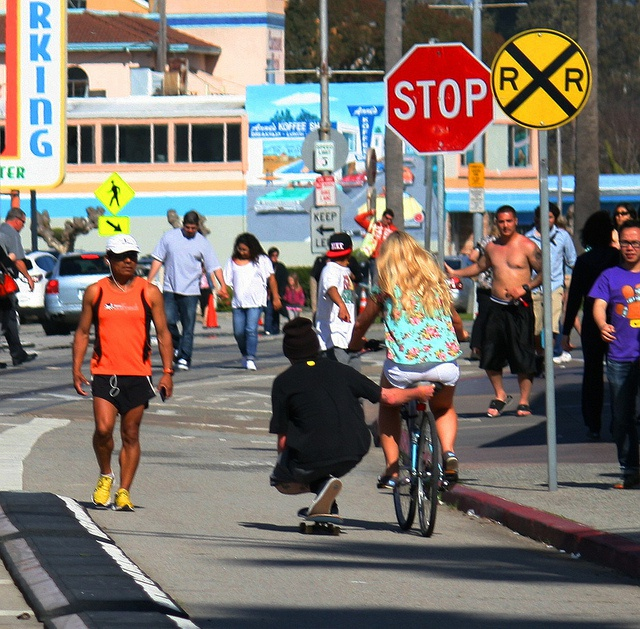Describe the objects in this image and their specific colors. I can see people in beige, red, black, maroon, and brown tones, people in beige, black, maroon, gray, and salmon tones, people in beige, tan, cyan, black, and lightgray tones, stop sign in beige, brown, lightgray, and lightblue tones, and people in beige, black, salmon, and brown tones in this image. 